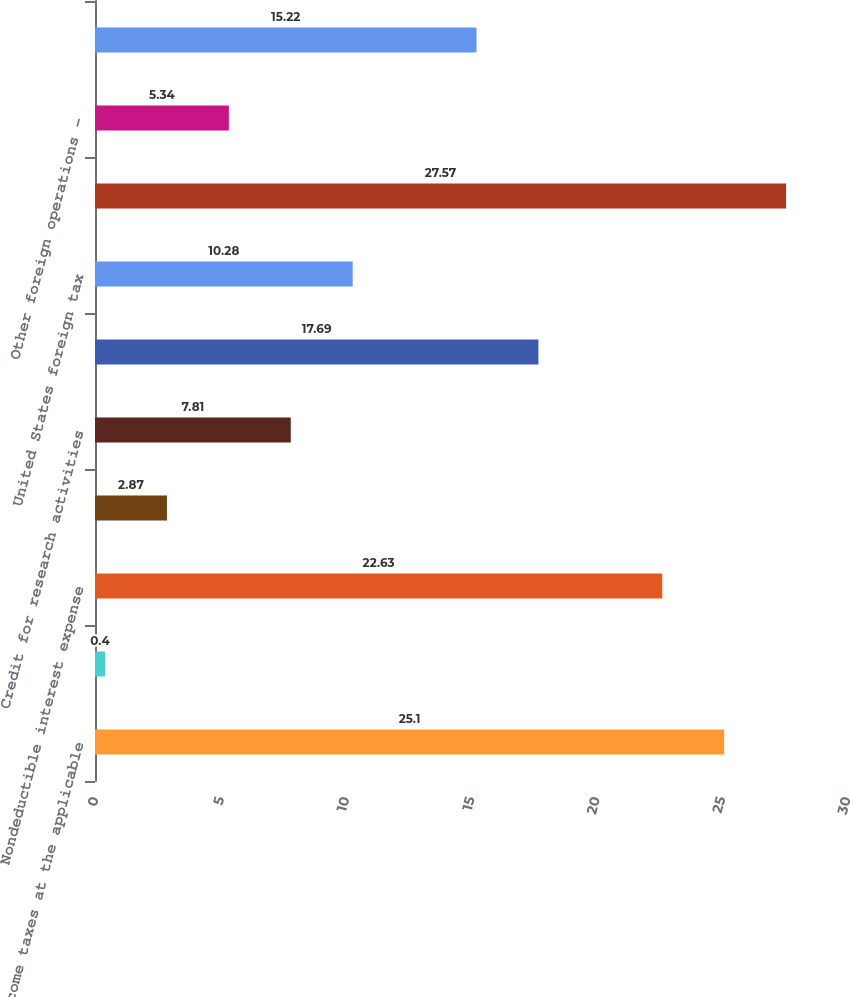Convert chart to OTSL. <chart><loc_0><loc_0><loc_500><loc_500><bar_chart><fcel>Income taxes at the applicable<fcel>Ireland tax on trading income<fcel>Nondeductible interest expense<fcel>United States (loss) income<fcel>Credit for research activities<fcel>Other - net<fcel>United States foreign tax<fcel>Other foreign operations<fcel>Other foreign operations -<fcel>Adjustments to tax liabilities<nl><fcel>25.1<fcel>0.4<fcel>22.63<fcel>2.87<fcel>7.81<fcel>17.69<fcel>10.28<fcel>27.57<fcel>5.34<fcel>15.22<nl></chart> 